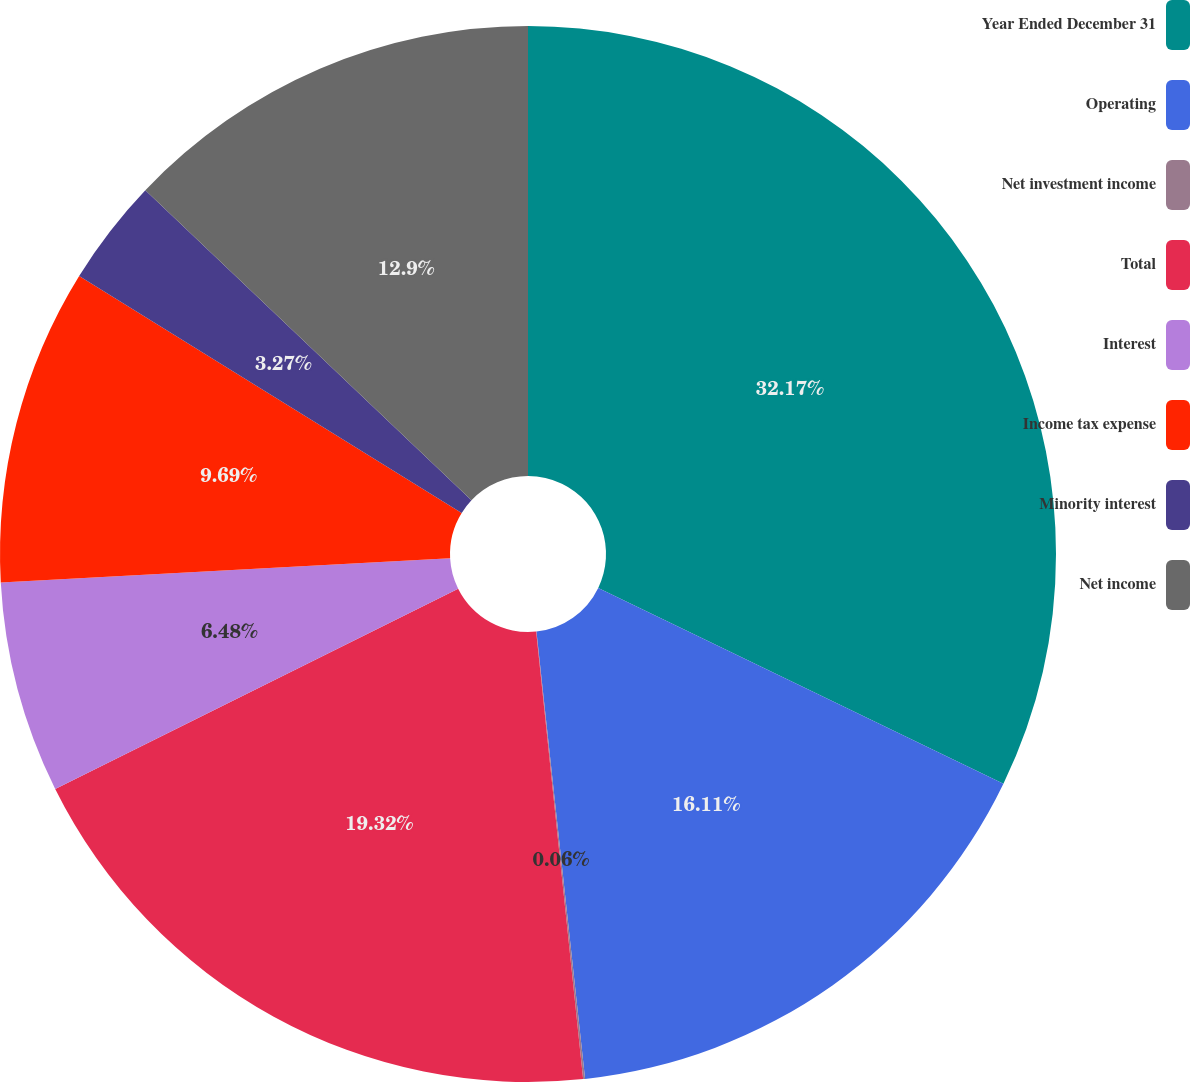Convert chart. <chart><loc_0><loc_0><loc_500><loc_500><pie_chart><fcel>Year Ended December 31<fcel>Operating<fcel>Net investment income<fcel>Total<fcel>Interest<fcel>Income tax expense<fcel>Minority interest<fcel>Net income<nl><fcel>32.16%<fcel>16.11%<fcel>0.06%<fcel>19.32%<fcel>6.48%<fcel>9.69%<fcel>3.27%<fcel>12.9%<nl></chart> 